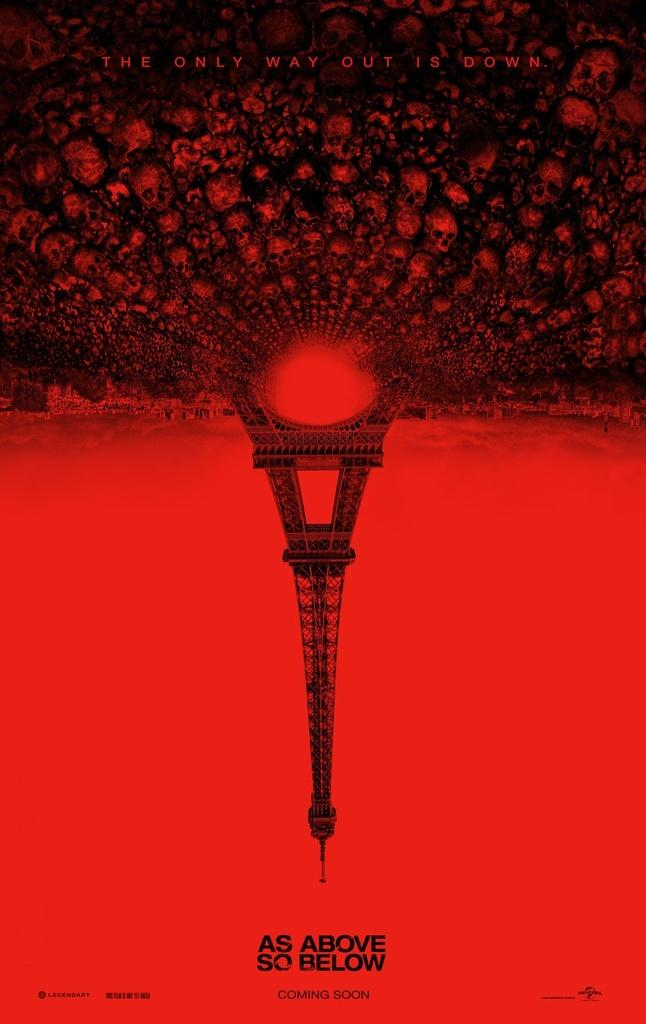What type of objects can be seen in the picture? There are skulls in the picture. What else is featured on the picture besides the skulls? There is text on top of the picture and the Eiffel Tower is present in the picture. Where is the text located at the bottom of the picture? The text is on an orange surface at the bottom of the picture. How many rings are visible on the skulls in the picture? There are no rings visible on the skulls in the picture. What type of experience can be gained from looking at the picture? The picture itself does not provide an experience; it is a static image. 